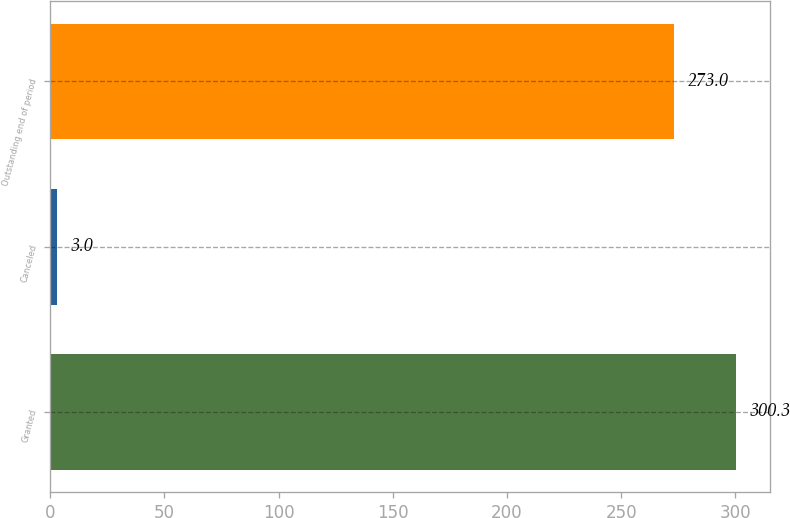<chart> <loc_0><loc_0><loc_500><loc_500><bar_chart><fcel>Granted<fcel>Canceled<fcel>Outstanding end of period<nl><fcel>300.3<fcel>3<fcel>273<nl></chart> 